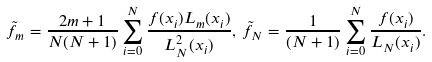<formula> <loc_0><loc_0><loc_500><loc_500>\tilde { f } _ { m } = \frac { 2 m + 1 } { N ( N + 1 ) } \sum _ { i = 0 } ^ { N } \frac { f ( x _ { i } ) L _ { m } ( x _ { i } ) } { L _ { N } ^ { 2 } ( x _ { i } ) } , \, \tilde { f } _ { N } = \frac { 1 } { ( N + 1 ) } \sum _ { i = 0 } ^ { N } \frac { f ( x _ { i } ) } { L _ { N } ( x _ { i } ) } .</formula> 